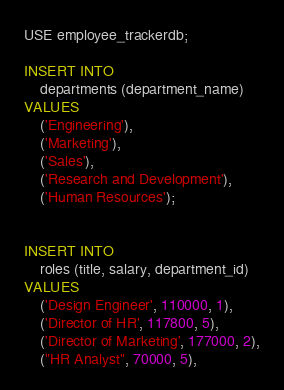<code> <loc_0><loc_0><loc_500><loc_500><_SQL_>USE employee_trackerdb;

INSERT INTO
    departments (department_name)
VALUES
    ('Engineering'),
    ('Marketing'),
    ('Sales'),
    ('Research and Development'),
    ('Human Resources');


INSERT INTO
    roles (title, salary, department_id)
VALUES
    ('Design Engineer', 110000, 1),
    ('Director of HR', 117800, 5),
    ('Director of Marketing', 177000, 2),
    ("HR Analyst", 70000, 5),</code> 